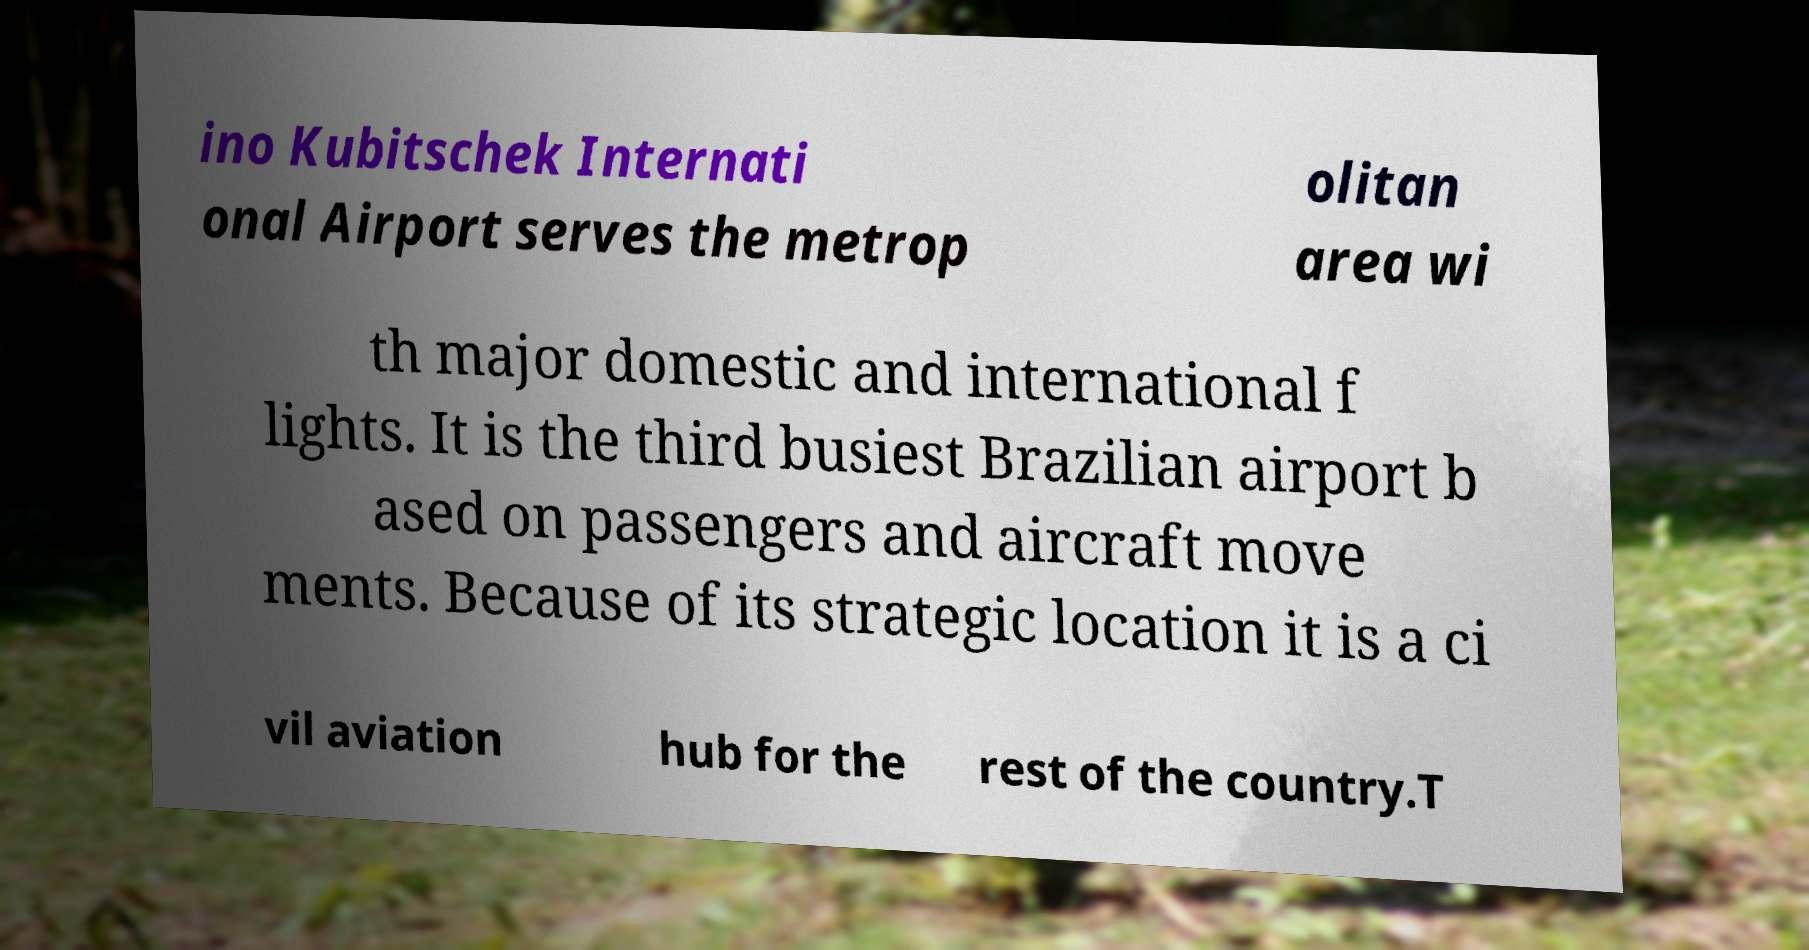There's text embedded in this image that I need extracted. Can you transcribe it verbatim? ino Kubitschek Internati onal Airport serves the metrop olitan area wi th major domestic and international f lights. It is the third busiest Brazilian airport b ased on passengers and aircraft move ments. Because of its strategic location it is a ci vil aviation hub for the rest of the country.T 